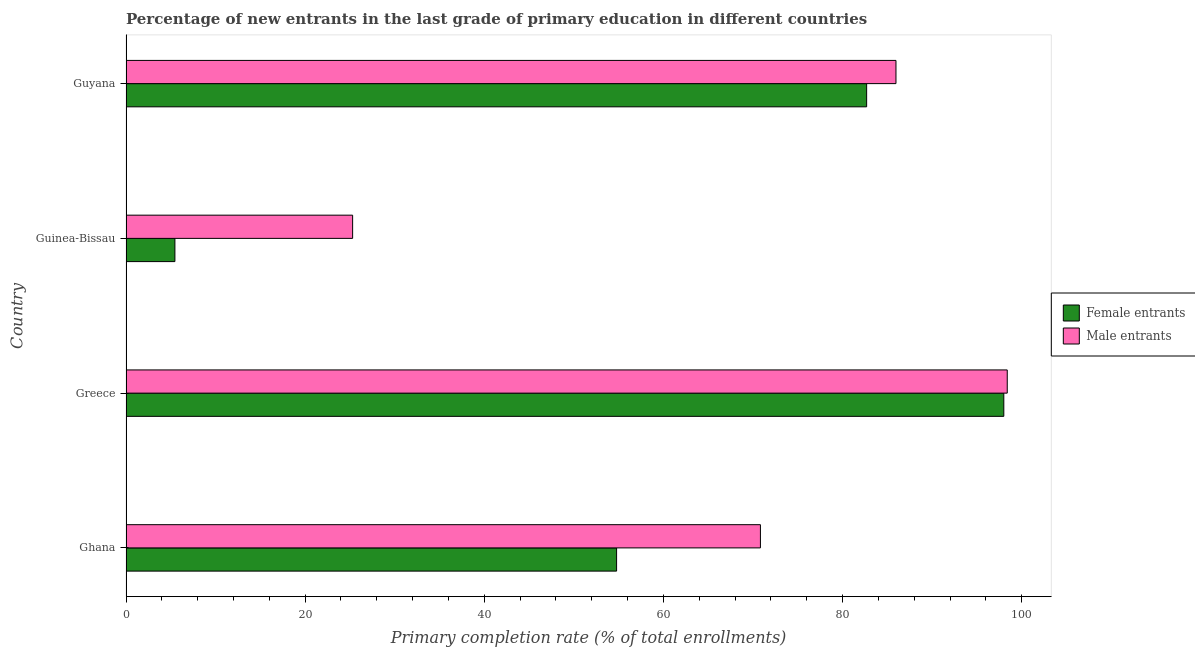How many bars are there on the 3rd tick from the top?
Provide a short and direct response. 2. What is the label of the 1st group of bars from the top?
Provide a succinct answer. Guyana. In how many cases, is the number of bars for a given country not equal to the number of legend labels?
Make the answer very short. 0. What is the primary completion rate of male entrants in Guinea-Bissau?
Your response must be concise. 25.3. Across all countries, what is the maximum primary completion rate of male entrants?
Provide a succinct answer. 98.39. Across all countries, what is the minimum primary completion rate of male entrants?
Make the answer very short. 25.3. In which country was the primary completion rate of male entrants minimum?
Keep it short and to the point. Guinea-Bissau. What is the total primary completion rate of female entrants in the graph?
Your answer should be compact. 240.93. What is the difference between the primary completion rate of female entrants in Ghana and that in Guyana?
Give a very brief answer. -27.92. What is the difference between the primary completion rate of female entrants in Ghana and the primary completion rate of male entrants in Guyana?
Give a very brief answer. -31.19. What is the average primary completion rate of male entrants per country?
Provide a short and direct response. 70.12. What is the difference between the primary completion rate of female entrants and primary completion rate of male entrants in Ghana?
Keep it short and to the point. -16.06. In how many countries, is the primary completion rate of male entrants greater than 44 %?
Your answer should be very brief. 3. What is the ratio of the primary completion rate of female entrants in Greece to that in Guyana?
Give a very brief answer. 1.19. What is the difference between the highest and the second highest primary completion rate of male entrants?
Your answer should be very brief. 12.42. What is the difference between the highest and the lowest primary completion rate of female entrants?
Make the answer very short. 92.55. In how many countries, is the primary completion rate of male entrants greater than the average primary completion rate of male entrants taken over all countries?
Offer a very short reply. 3. What does the 2nd bar from the top in Ghana represents?
Make the answer very short. Female entrants. What does the 1st bar from the bottom in Ghana represents?
Offer a very short reply. Female entrants. How many bars are there?
Give a very brief answer. 8. Does the graph contain grids?
Keep it short and to the point. No. Where does the legend appear in the graph?
Provide a short and direct response. Center right. How are the legend labels stacked?
Your answer should be very brief. Vertical. What is the title of the graph?
Your response must be concise. Percentage of new entrants in the last grade of primary education in different countries. What is the label or title of the X-axis?
Give a very brief answer. Primary completion rate (% of total enrollments). What is the label or title of the Y-axis?
Make the answer very short. Country. What is the Primary completion rate (% of total enrollments) in Female entrants in Ghana?
Provide a short and direct response. 54.77. What is the Primary completion rate (% of total enrollments) in Male entrants in Ghana?
Give a very brief answer. 70.83. What is the Primary completion rate (% of total enrollments) of Female entrants in Greece?
Provide a short and direct response. 98.01. What is the Primary completion rate (% of total enrollments) in Male entrants in Greece?
Offer a terse response. 98.39. What is the Primary completion rate (% of total enrollments) of Female entrants in Guinea-Bissau?
Provide a succinct answer. 5.46. What is the Primary completion rate (% of total enrollments) in Male entrants in Guinea-Bissau?
Your answer should be compact. 25.3. What is the Primary completion rate (% of total enrollments) in Female entrants in Guyana?
Make the answer very short. 82.69. What is the Primary completion rate (% of total enrollments) of Male entrants in Guyana?
Ensure brevity in your answer.  85.96. Across all countries, what is the maximum Primary completion rate (% of total enrollments) of Female entrants?
Give a very brief answer. 98.01. Across all countries, what is the maximum Primary completion rate (% of total enrollments) in Male entrants?
Offer a terse response. 98.39. Across all countries, what is the minimum Primary completion rate (% of total enrollments) of Female entrants?
Ensure brevity in your answer.  5.46. Across all countries, what is the minimum Primary completion rate (% of total enrollments) of Male entrants?
Provide a succinct answer. 25.3. What is the total Primary completion rate (% of total enrollments) in Female entrants in the graph?
Keep it short and to the point. 240.93. What is the total Primary completion rate (% of total enrollments) of Male entrants in the graph?
Offer a very short reply. 280.49. What is the difference between the Primary completion rate (% of total enrollments) of Female entrants in Ghana and that in Greece?
Ensure brevity in your answer.  -43.23. What is the difference between the Primary completion rate (% of total enrollments) of Male entrants in Ghana and that in Greece?
Your answer should be compact. -27.56. What is the difference between the Primary completion rate (% of total enrollments) in Female entrants in Ghana and that in Guinea-Bissau?
Your answer should be compact. 49.31. What is the difference between the Primary completion rate (% of total enrollments) in Male entrants in Ghana and that in Guinea-Bissau?
Provide a succinct answer. 45.53. What is the difference between the Primary completion rate (% of total enrollments) in Female entrants in Ghana and that in Guyana?
Offer a terse response. -27.92. What is the difference between the Primary completion rate (% of total enrollments) in Male entrants in Ghana and that in Guyana?
Your answer should be compact. -15.13. What is the difference between the Primary completion rate (% of total enrollments) of Female entrants in Greece and that in Guinea-Bissau?
Your response must be concise. 92.55. What is the difference between the Primary completion rate (% of total enrollments) of Male entrants in Greece and that in Guinea-Bissau?
Provide a short and direct response. 73.09. What is the difference between the Primary completion rate (% of total enrollments) in Female entrants in Greece and that in Guyana?
Offer a very short reply. 15.32. What is the difference between the Primary completion rate (% of total enrollments) of Male entrants in Greece and that in Guyana?
Your answer should be very brief. 12.42. What is the difference between the Primary completion rate (% of total enrollments) of Female entrants in Guinea-Bissau and that in Guyana?
Keep it short and to the point. -77.23. What is the difference between the Primary completion rate (% of total enrollments) of Male entrants in Guinea-Bissau and that in Guyana?
Your answer should be compact. -60.66. What is the difference between the Primary completion rate (% of total enrollments) of Female entrants in Ghana and the Primary completion rate (% of total enrollments) of Male entrants in Greece?
Give a very brief answer. -43.61. What is the difference between the Primary completion rate (% of total enrollments) in Female entrants in Ghana and the Primary completion rate (% of total enrollments) in Male entrants in Guinea-Bissau?
Your answer should be very brief. 29.47. What is the difference between the Primary completion rate (% of total enrollments) of Female entrants in Ghana and the Primary completion rate (% of total enrollments) of Male entrants in Guyana?
Make the answer very short. -31.19. What is the difference between the Primary completion rate (% of total enrollments) in Female entrants in Greece and the Primary completion rate (% of total enrollments) in Male entrants in Guinea-Bissau?
Your response must be concise. 72.71. What is the difference between the Primary completion rate (% of total enrollments) in Female entrants in Greece and the Primary completion rate (% of total enrollments) in Male entrants in Guyana?
Your response must be concise. 12.04. What is the difference between the Primary completion rate (% of total enrollments) in Female entrants in Guinea-Bissau and the Primary completion rate (% of total enrollments) in Male entrants in Guyana?
Offer a terse response. -80.5. What is the average Primary completion rate (% of total enrollments) of Female entrants per country?
Offer a terse response. 60.23. What is the average Primary completion rate (% of total enrollments) of Male entrants per country?
Your response must be concise. 70.12. What is the difference between the Primary completion rate (% of total enrollments) in Female entrants and Primary completion rate (% of total enrollments) in Male entrants in Ghana?
Your response must be concise. -16.06. What is the difference between the Primary completion rate (% of total enrollments) in Female entrants and Primary completion rate (% of total enrollments) in Male entrants in Greece?
Your answer should be compact. -0.38. What is the difference between the Primary completion rate (% of total enrollments) in Female entrants and Primary completion rate (% of total enrollments) in Male entrants in Guinea-Bissau?
Keep it short and to the point. -19.84. What is the difference between the Primary completion rate (% of total enrollments) in Female entrants and Primary completion rate (% of total enrollments) in Male entrants in Guyana?
Your answer should be compact. -3.27. What is the ratio of the Primary completion rate (% of total enrollments) of Female entrants in Ghana to that in Greece?
Keep it short and to the point. 0.56. What is the ratio of the Primary completion rate (% of total enrollments) in Male entrants in Ghana to that in Greece?
Provide a succinct answer. 0.72. What is the ratio of the Primary completion rate (% of total enrollments) in Female entrants in Ghana to that in Guinea-Bissau?
Give a very brief answer. 10.03. What is the ratio of the Primary completion rate (% of total enrollments) in Male entrants in Ghana to that in Guinea-Bissau?
Your answer should be very brief. 2.8. What is the ratio of the Primary completion rate (% of total enrollments) in Female entrants in Ghana to that in Guyana?
Offer a terse response. 0.66. What is the ratio of the Primary completion rate (% of total enrollments) of Male entrants in Ghana to that in Guyana?
Make the answer very short. 0.82. What is the ratio of the Primary completion rate (% of total enrollments) of Female entrants in Greece to that in Guinea-Bissau?
Ensure brevity in your answer.  17.95. What is the ratio of the Primary completion rate (% of total enrollments) of Male entrants in Greece to that in Guinea-Bissau?
Offer a terse response. 3.89. What is the ratio of the Primary completion rate (% of total enrollments) of Female entrants in Greece to that in Guyana?
Your answer should be very brief. 1.19. What is the ratio of the Primary completion rate (% of total enrollments) of Male entrants in Greece to that in Guyana?
Your response must be concise. 1.14. What is the ratio of the Primary completion rate (% of total enrollments) of Female entrants in Guinea-Bissau to that in Guyana?
Make the answer very short. 0.07. What is the ratio of the Primary completion rate (% of total enrollments) of Male entrants in Guinea-Bissau to that in Guyana?
Provide a short and direct response. 0.29. What is the difference between the highest and the second highest Primary completion rate (% of total enrollments) of Female entrants?
Provide a succinct answer. 15.32. What is the difference between the highest and the second highest Primary completion rate (% of total enrollments) in Male entrants?
Keep it short and to the point. 12.42. What is the difference between the highest and the lowest Primary completion rate (% of total enrollments) in Female entrants?
Your answer should be compact. 92.55. What is the difference between the highest and the lowest Primary completion rate (% of total enrollments) in Male entrants?
Offer a very short reply. 73.09. 